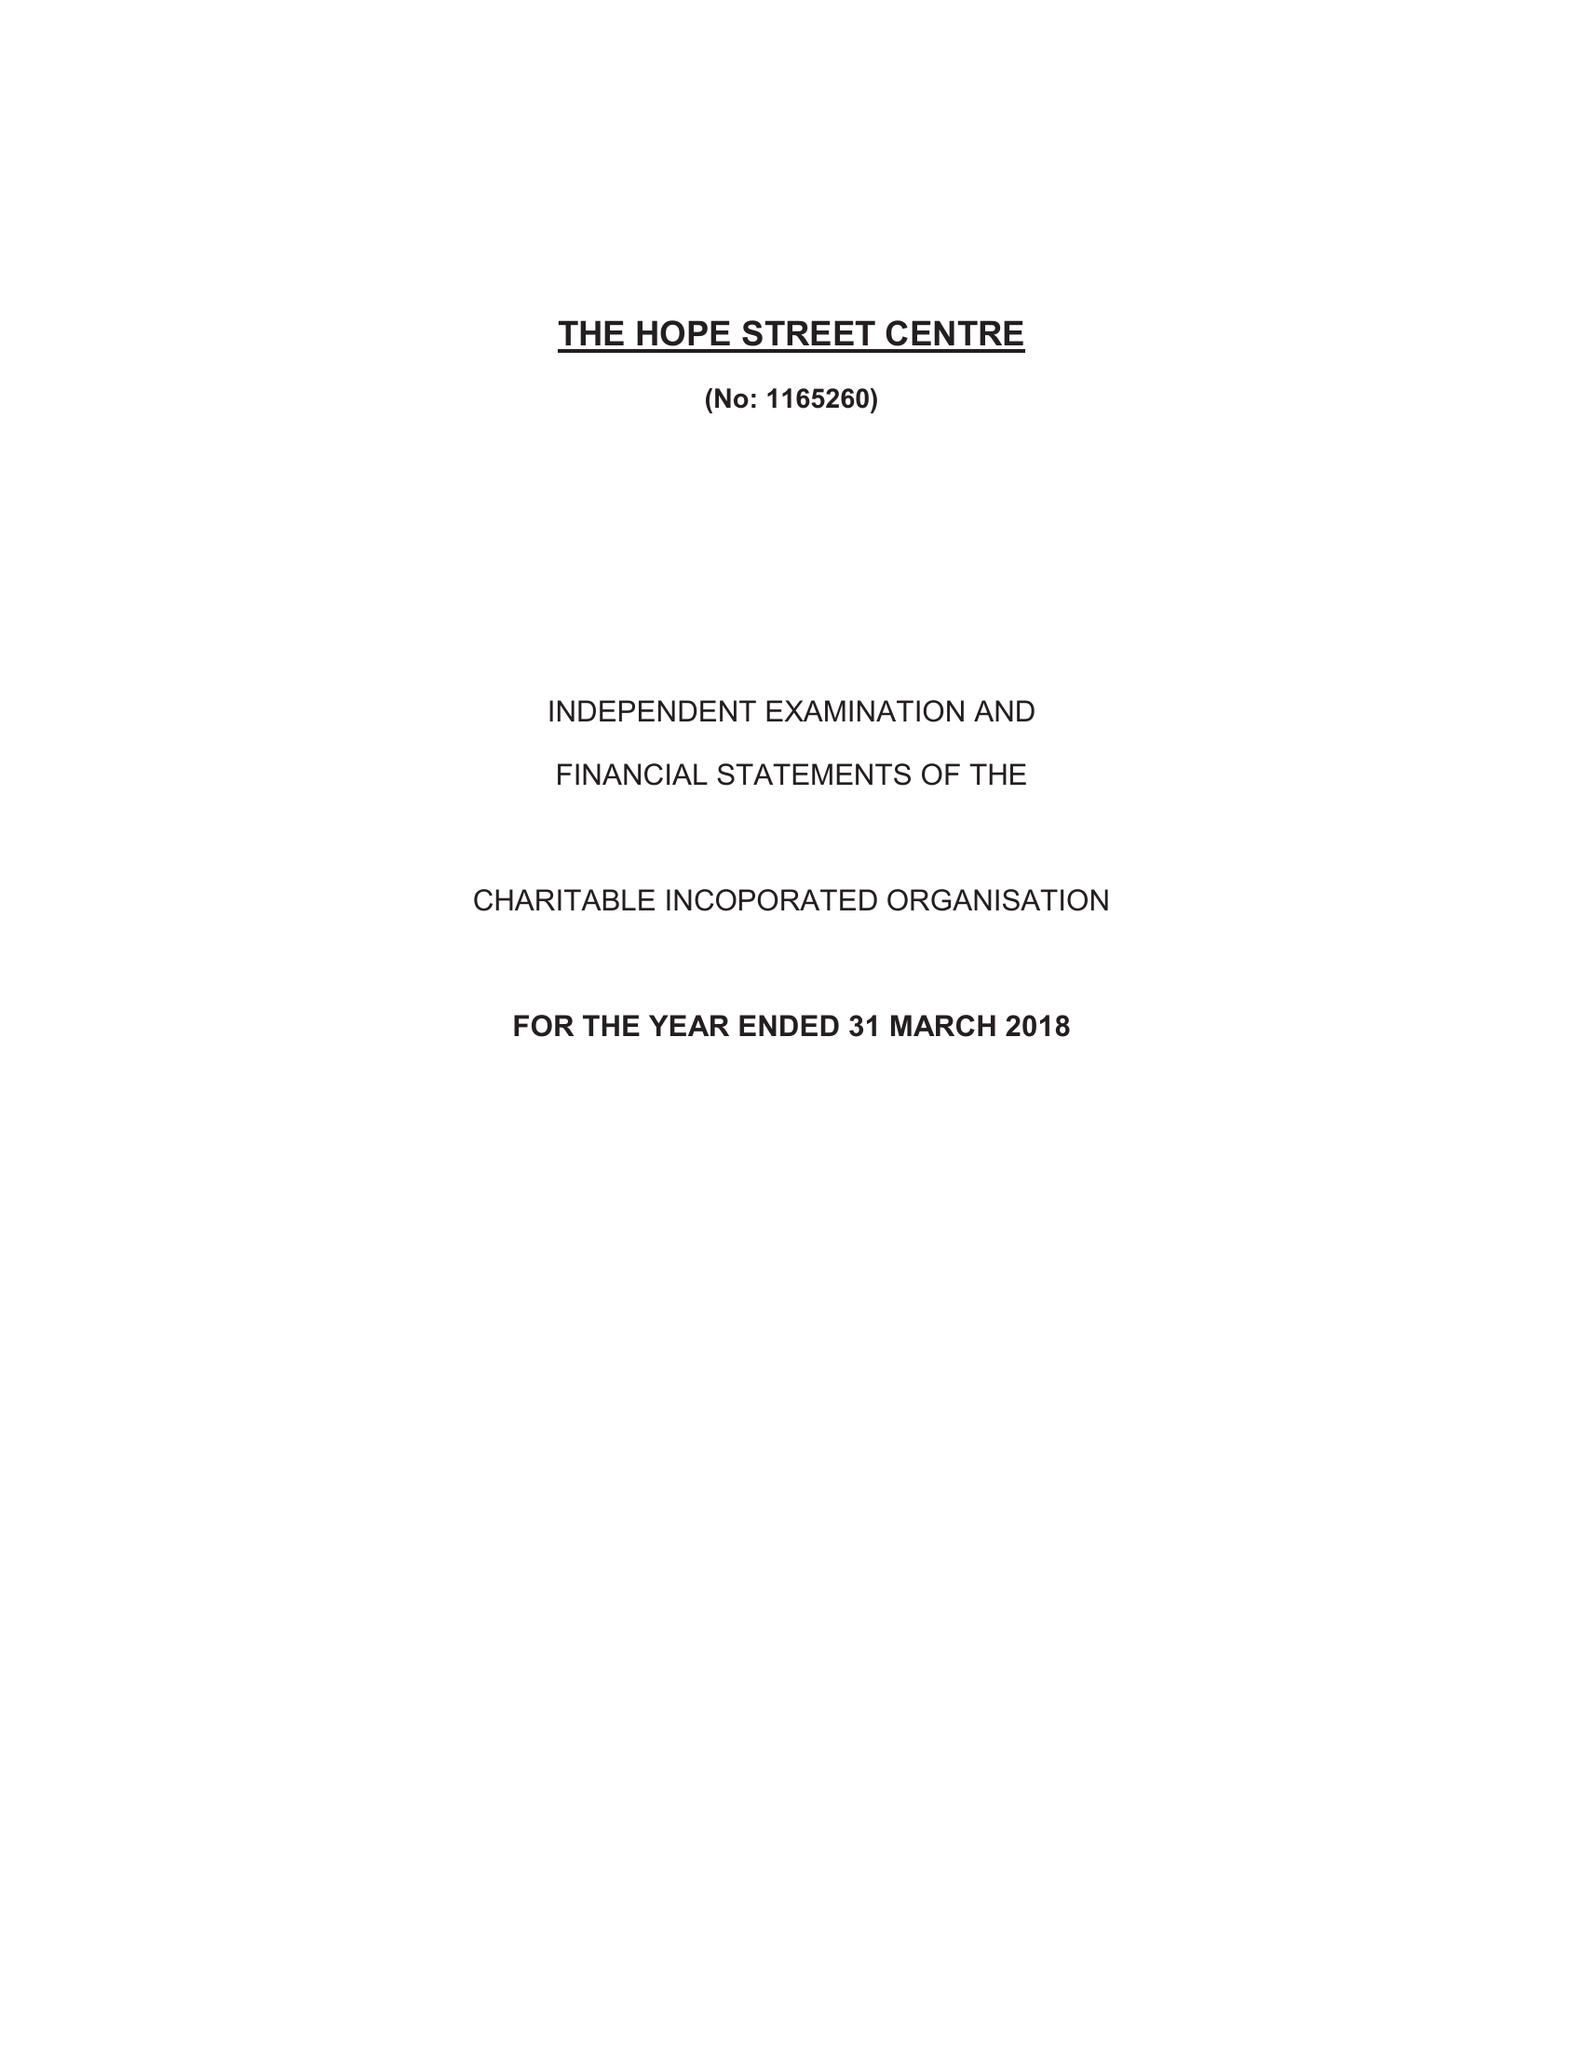What is the value for the charity_number?
Answer the question using a single word or phrase. 1165260 